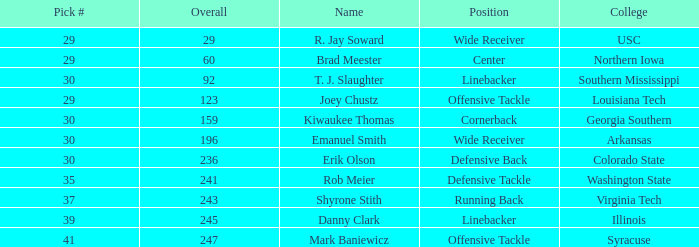Would you be able to parse every entry in this table? {'header': ['Pick #', 'Overall', 'Name', 'Position', 'College'], 'rows': [['29', '29', 'R. Jay Soward', 'Wide Receiver', 'USC'], ['29', '60', 'Brad Meester', 'Center', 'Northern Iowa'], ['30', '92', 'T. J. Slaughter', 'Linebacker', 'Southern Mississippi'], ['29', '123', 'Joey Chustz', 'Offensive Tackle', 'Louisiana Tech'], ['30', '159', 'Kiwaukee Thomas', 'Cornerback', 'Georgia Southern'], ['30', '196', 'Emanuel Smith', 'Wide Receiver', 'Arkansas'], ['30', '236', 'Erik Olson', 'Defensive Back', 'Colorado State'], ['35', '241', 'Rob Meier', 'Defensive Tackle', 'Washington State'], ['37', '243', 'Shyrone Stith', 'Running Back', 'Virginia Tech'], ['39', '245', 'Danny Clark', 'Linebacker', 'Illinois'], ['41', '247', 'Mark Baniewicz', 'Offensive Tackle', 'Syracuse']]} What is the average Round for wide receiver r. jay soward and Overall smaller than 29? None. 